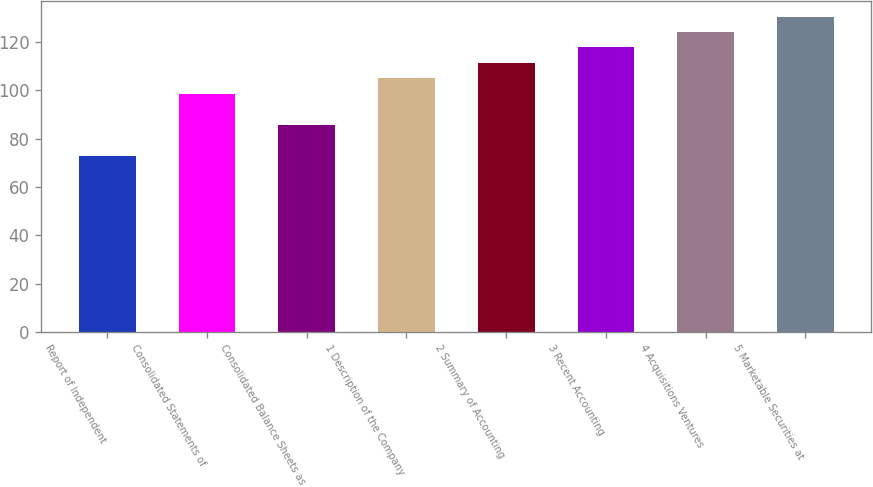<chart> <loc_0><loc_0><loc_500><loc_500><bar_chart><fcel>Report of Independent<fcel>Consolidated Statements of<fcel>Consolidated Balance Sheets as<fcel>1 Description of the Company<fcel>2 Summary of Accounting<fcel>3 Recent Accounting<fcel>4 Acquisitions Ventures<fcel>5 Marketable Securities at<nl><fcel>73<fcel>98.6<fcel>85.8<fcel>105<fcel>111.4<fcel>117.8<fcel>124.2<fcel>130.6<nl></chart> 